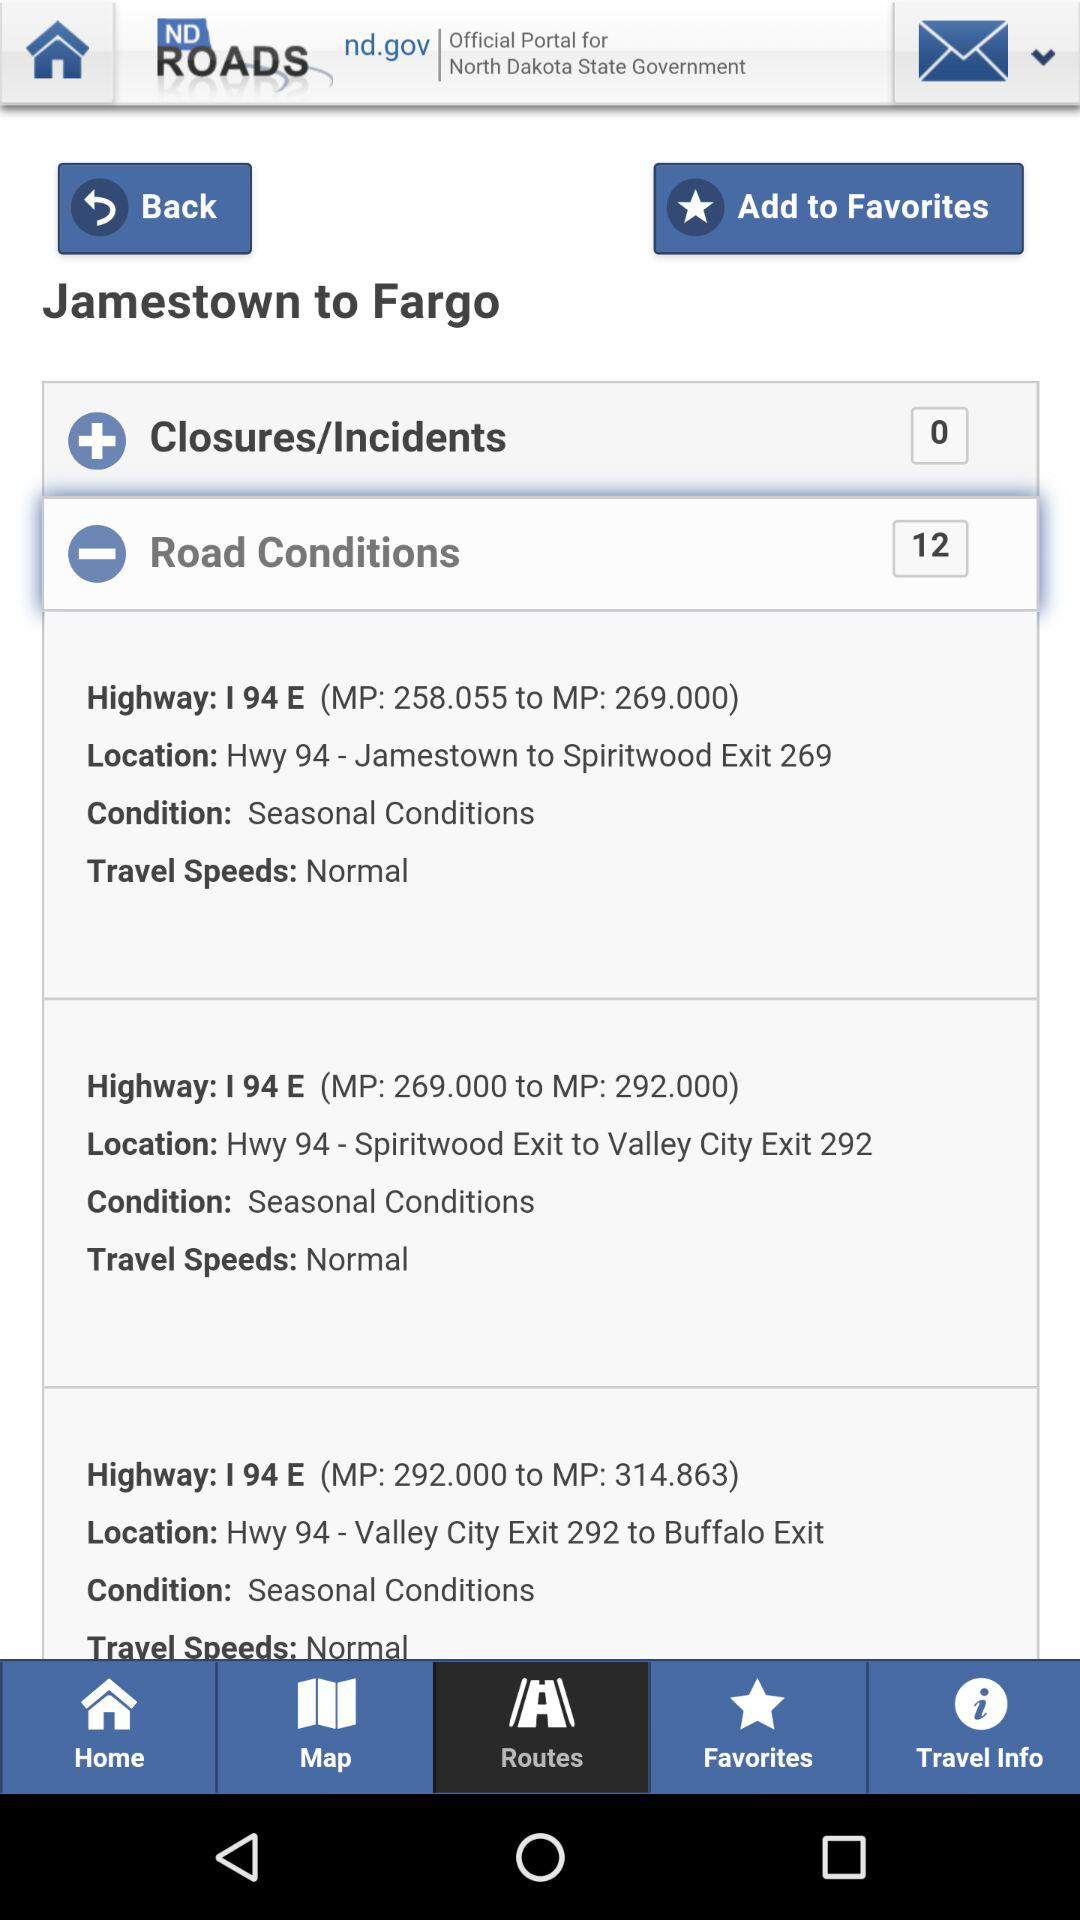Where is it to? It is to Fargo. 